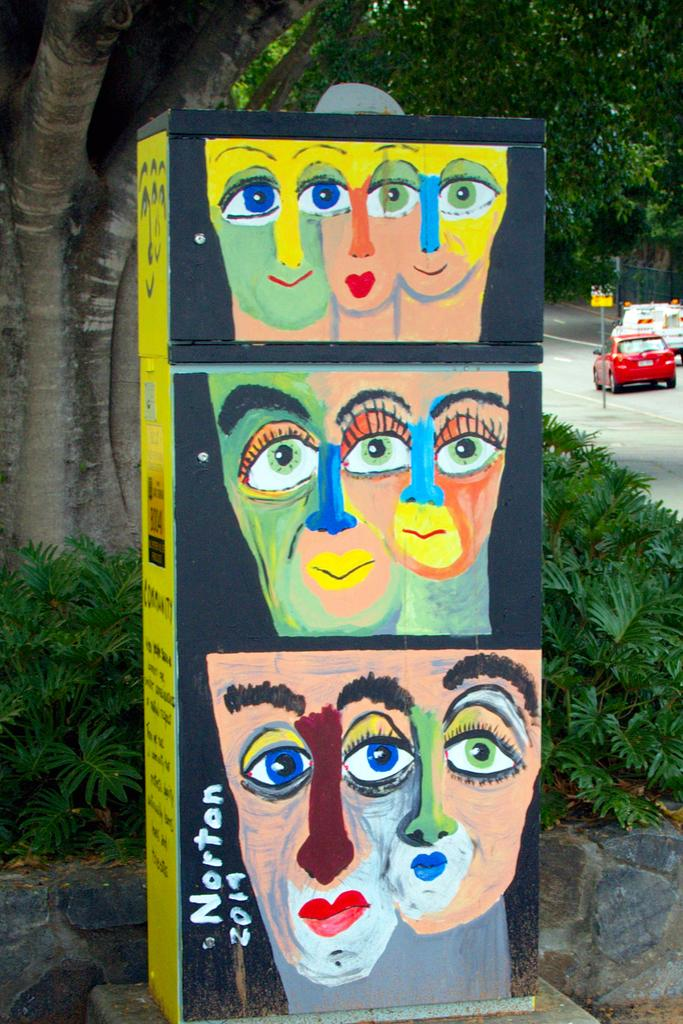What is on the box that is visible in the image? There is a painting on the box, and there is also text. What type of vegetation can be seen in the image? There are plants and trees in the image. What can be seen in the background of the image? Vehicles are visible on the road, and there is a pole with a board in the background. How many beads are hanging from the fang of the snake in the image? There is no snake or beads present in the image. What type of coil is visible on the ground in the image? There is no coil visible on the ground in the image. 